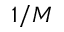Convert formula to latex. <formula><loc_0><loc_0><loc_500><loc_500>1 / M</formula> 